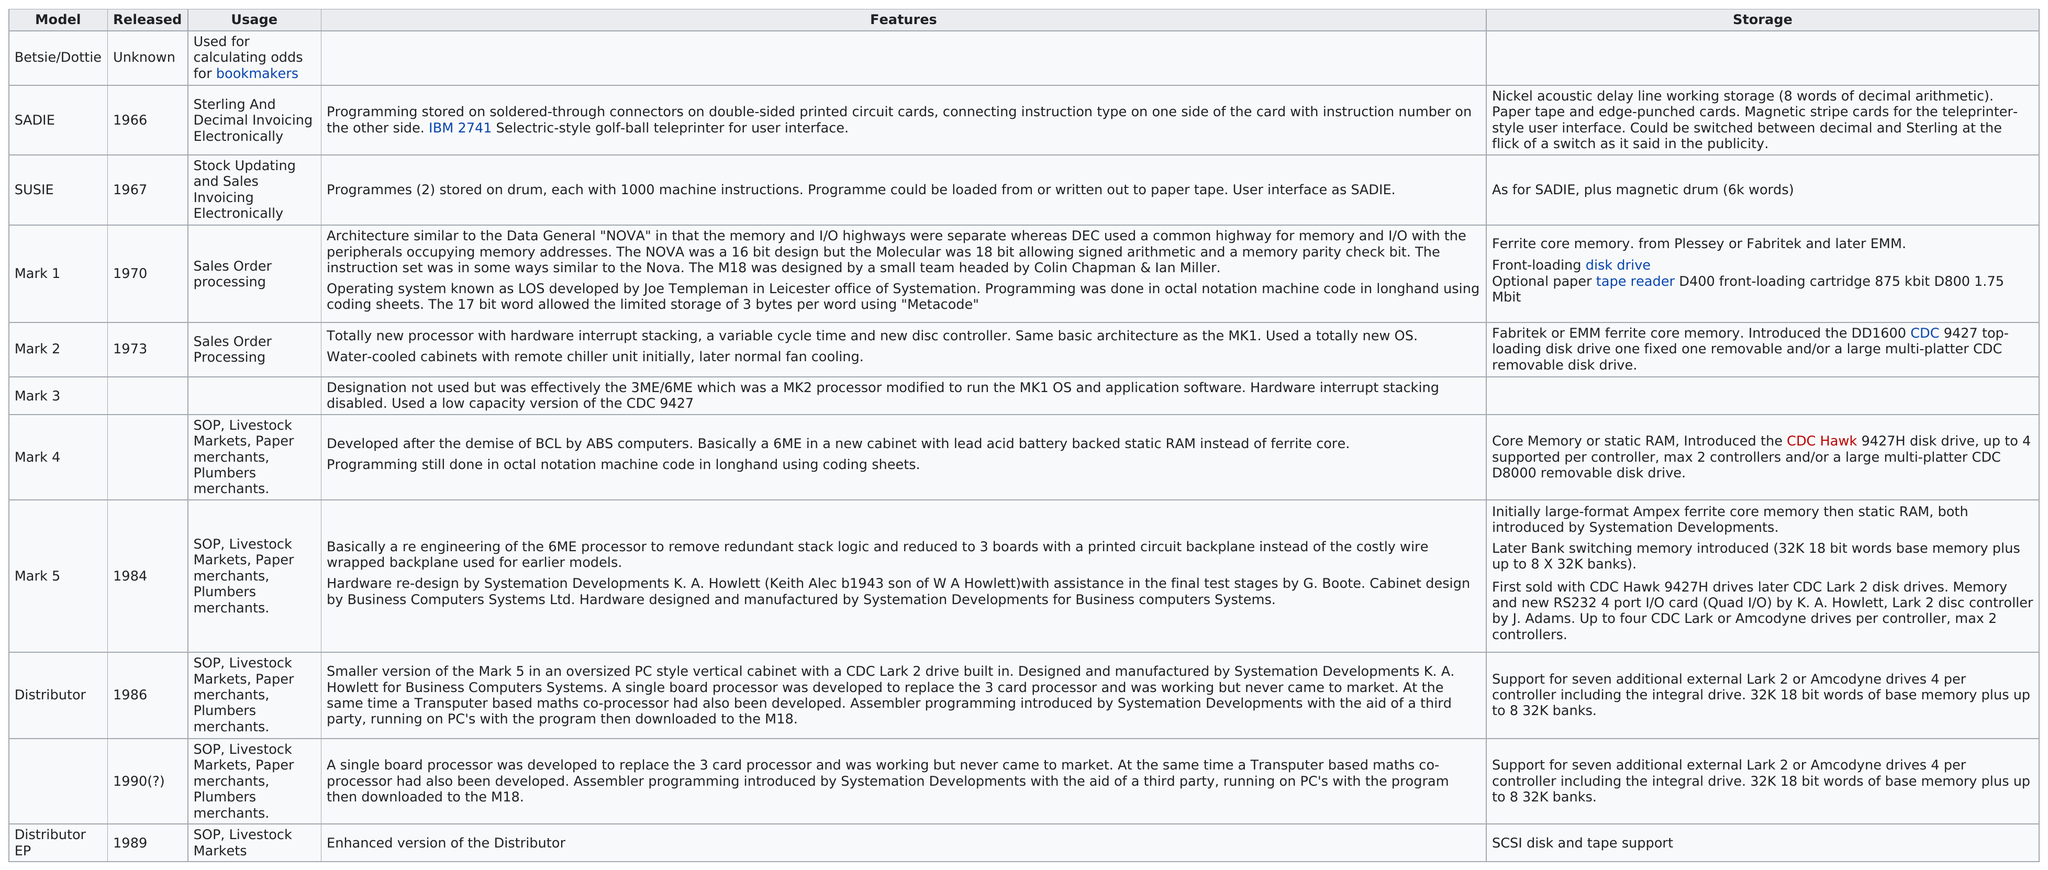Highlight a few significant elements in this photo. What was the most recent release? 1990... One name that was released in the 1980s but was not used for plumbers merchants is Distributor EP. Please name the model that has no information listed under the 'usage' category. The distributor was not present before Mark 5 was inserted. After Susie, the next person was Mark 1... 